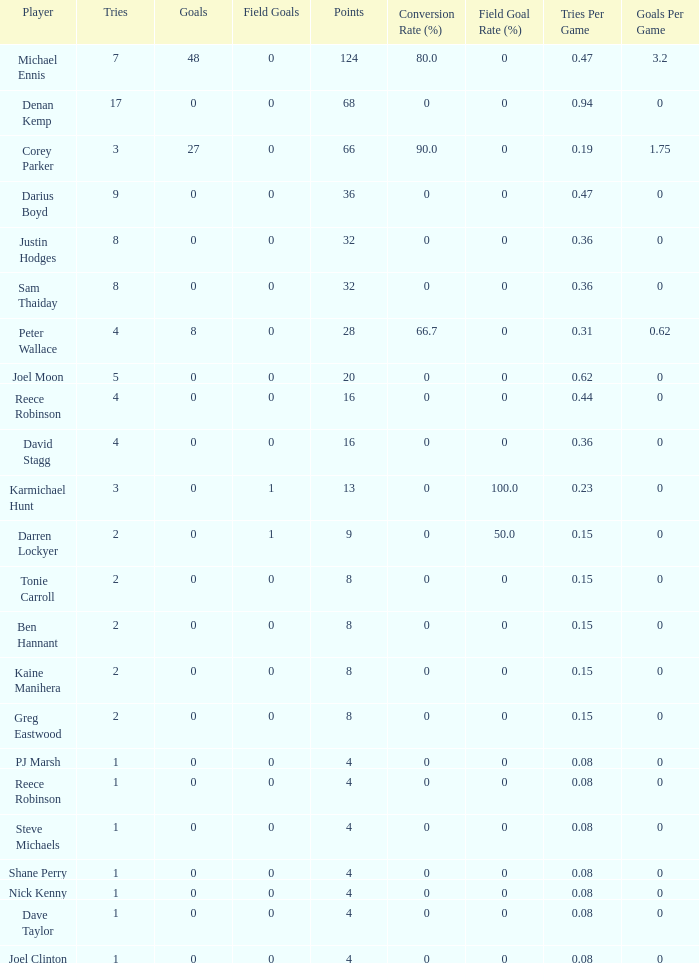How many goals did the player with less than 4 points have? 0.0. 